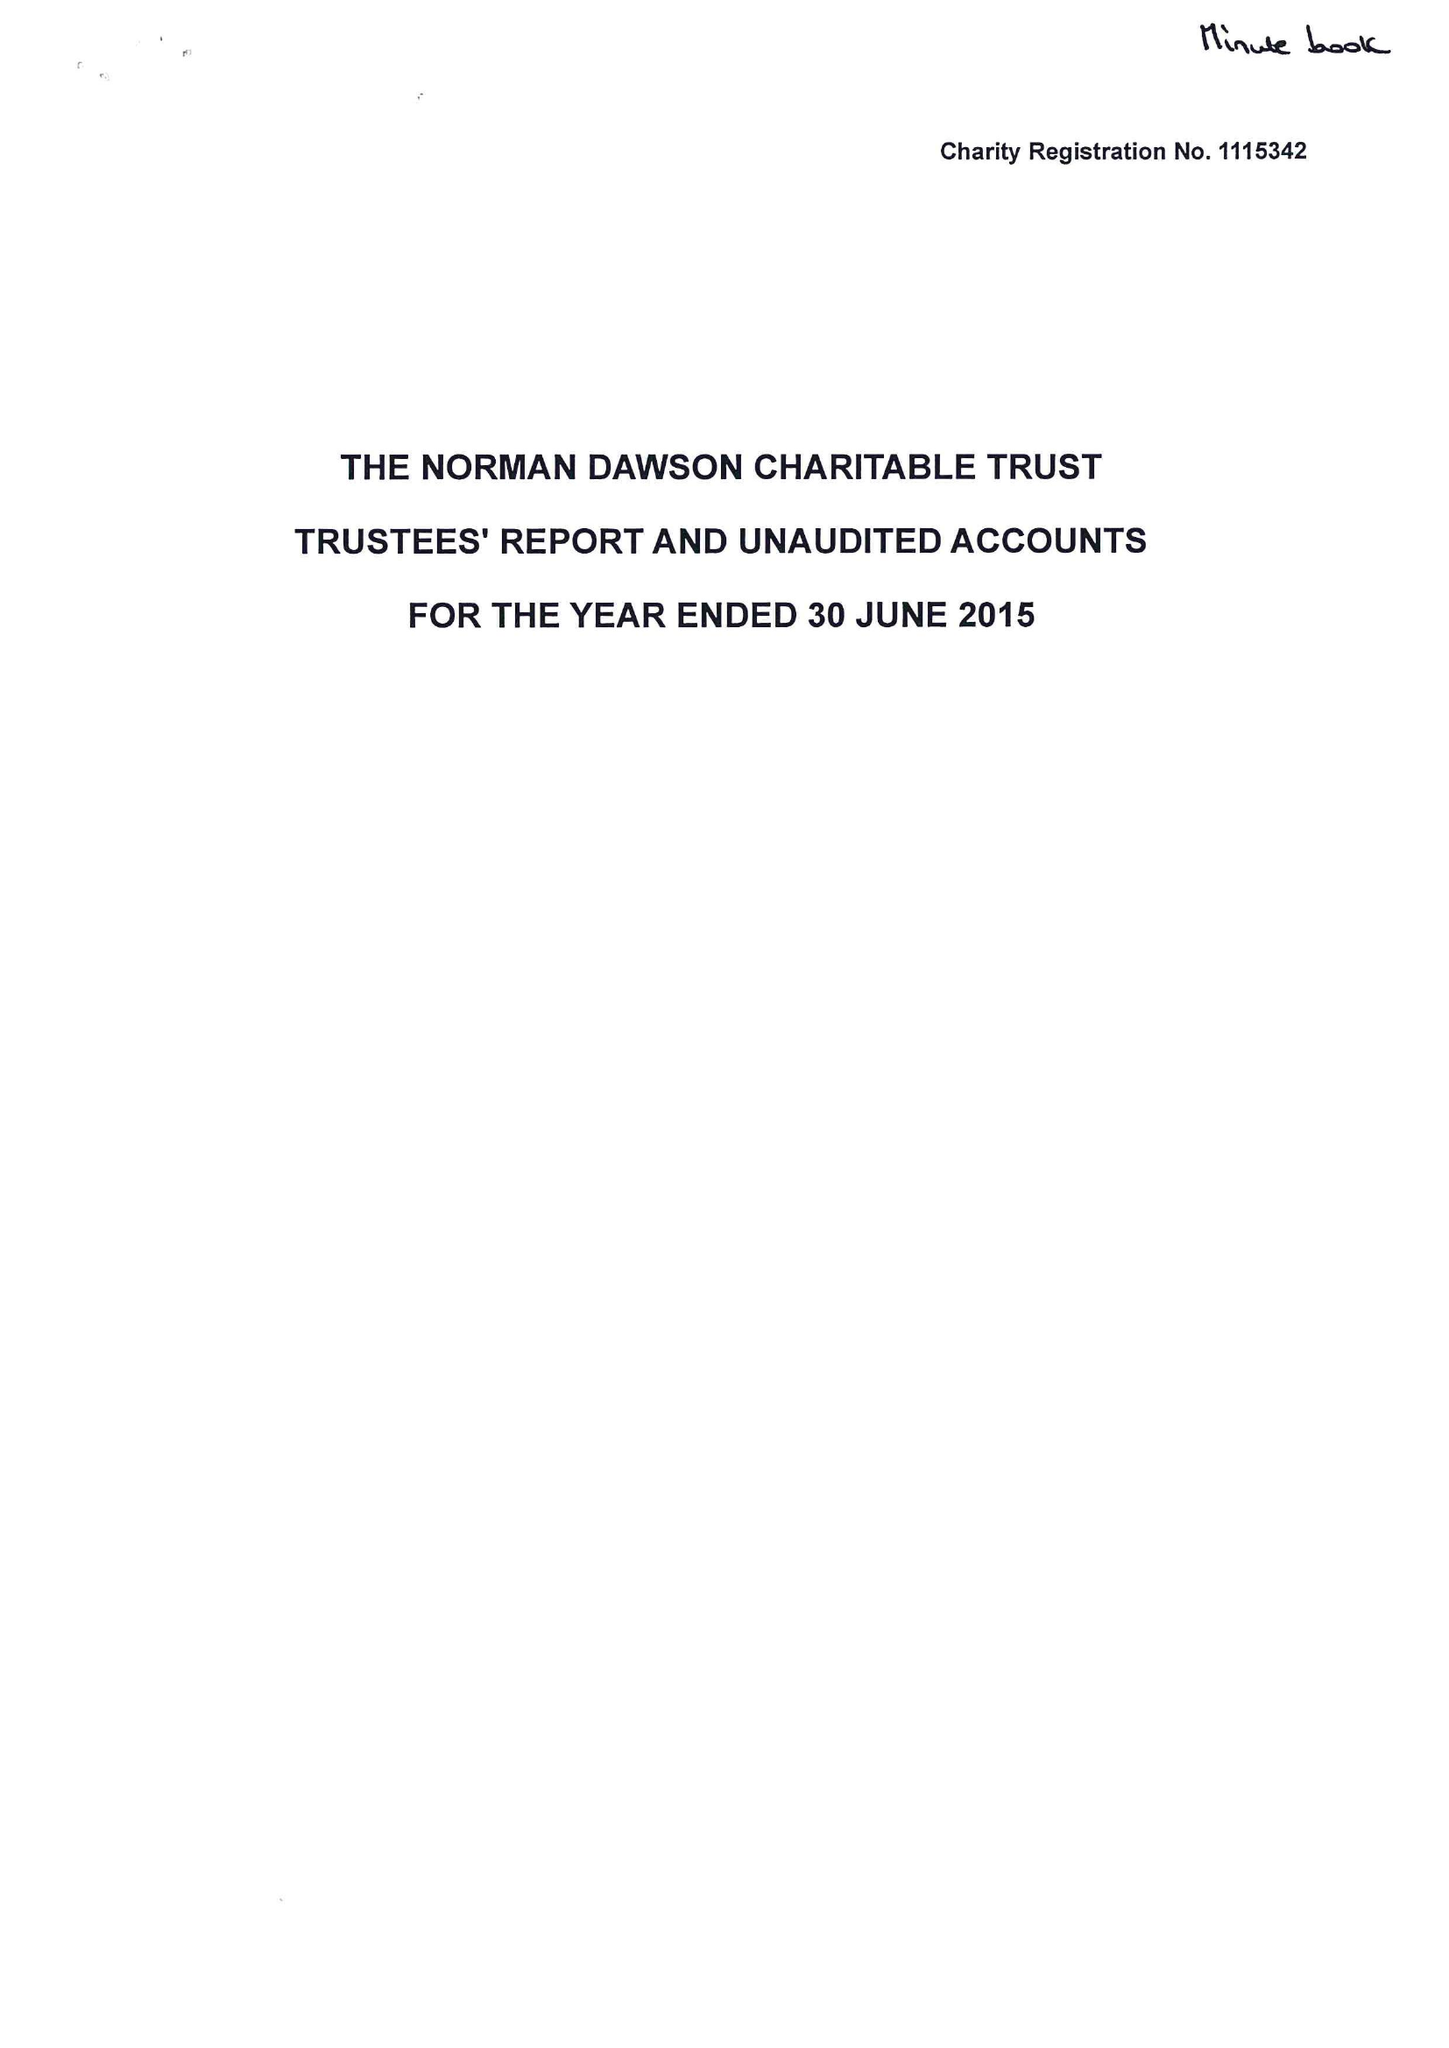What is the value for the address__postcode?
Answer the question using a single word or phrase. DY10 2SA 